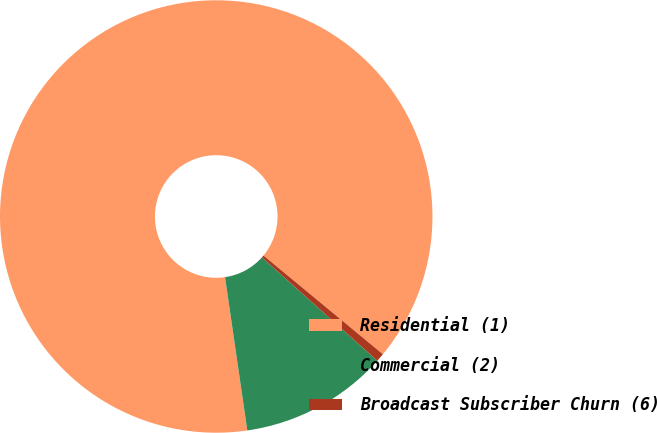Convert chart. <chart><loc_0><loc_0><loc_500><loc_500><pie_chart><fcel>Residential (1)<fcel>Commercial (2)<fcel>Broadcast Subscriber Churn (6)<nl><fcel>88.29%<fcel>11.08%<fcel>0.63%<nl></chart> 